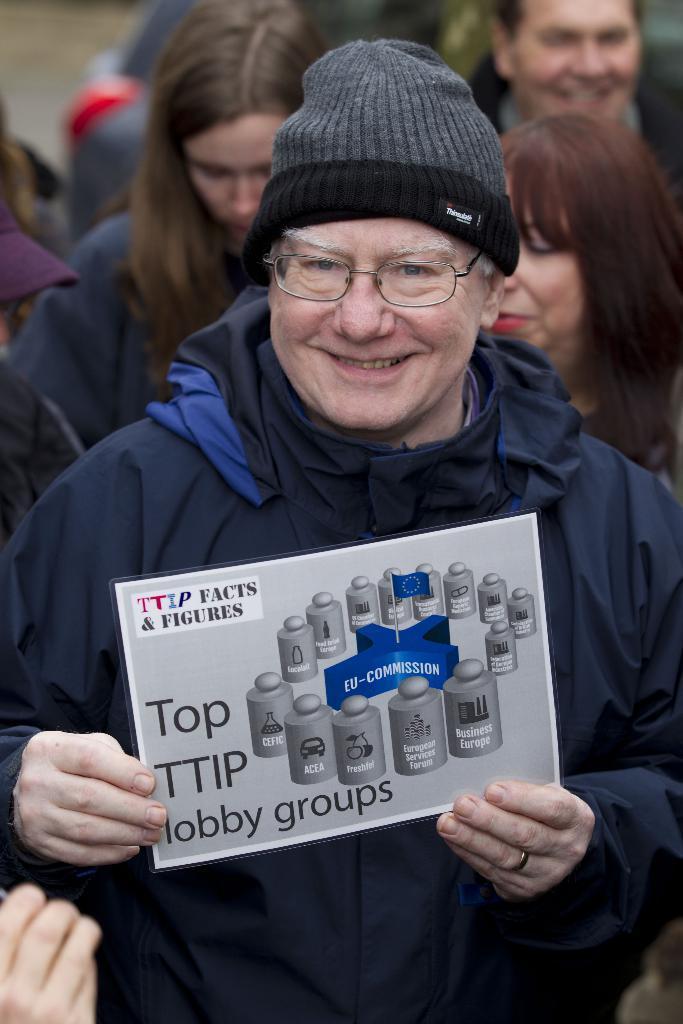In one or two sentences, can you explain what this image depicts? In this image we can see a person posing for a picture and holding a poster which consists of some text and logos, behind him there are a group of people standing. 